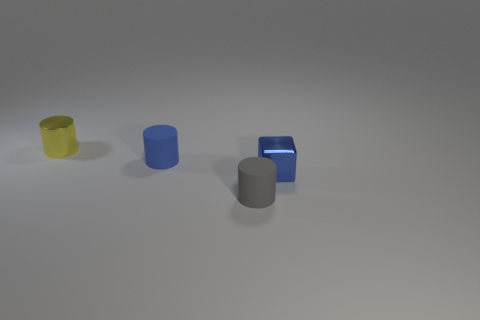Subtract all small gray cylinders. How many cylinders are left? 2 Add 3 large purple spheres. How many objects exist? 7 Subtract all purple cylinders. Subtract all red blocks. How many cylinders are left? 3 Subtract all yellow things. Subtract all tiny blue cubes. How many objects are left? 2 Add 4 tiny blue matte objects. How many tiny blue matte objects are left? 5 Add 2 blue cubes. How many blue cubes exist? 3 Subtract 0 brown spheres. How many objects are left? 4 Subtract all cubes. How many objects are left? 3 